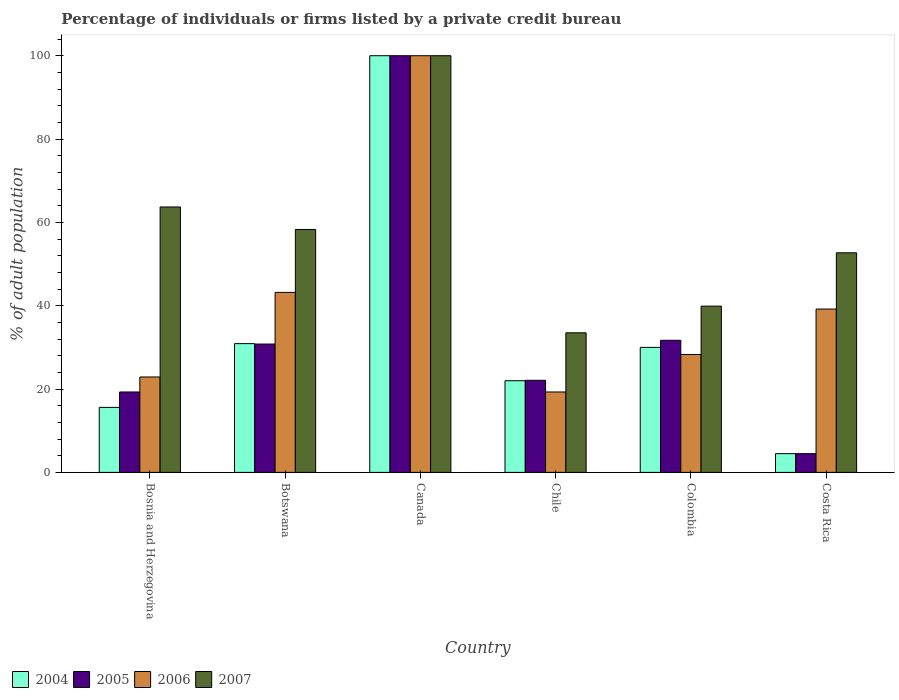How many groups of bars are there?
Make the answer very short. 6. Are the number of bars on each tick of the X-axis equal?
Your answer should be compact. Yes. How many bars are there on the 2nd tick from the right?
Offer a very short reply. 4. What is the percentage of population listed by a private credit bureau in 2005 in Colombia?
Offer a very short reply. 31.7. Across all countries, what is the maximum percentage of population listed by a private credit bureau in 2005?
Your response must be concise. 100. Across all countries, what is the minimum percentage of population listed by a private credit bureau in 2005?
Keep it short and to the point. 4.5. In which country was the percentage of population listed by a private credit bureau in 2005 maximum?
Provide a short and direct response. Canada. In which country was the percentage of population listed by a private credit bureau in 2007 minimum?
Your response must be concise. Chile. What is the total percentage of population listed by a private credit bureau in 2006 in the graph?
Make the answer very short. 252.9. What is the difference between the percentage of population listed by a private credit bureau in 2005 in Bosnia and Herzegovina and that in Canada?
Provide a short and direct response. -80.7. What is the difference between the percentage of population listed by a private credit bureau in 2005 in Canada and the percentage of population listed by a private credit bureau in 2006 in Colombia?
Your answer should be compact. 71.7. What is the average percentage of population listed by a private credit bureau in 2006 per country?
Provide a succinct answer. 42.15. What is the difference between the percentage of population listed by a private credit bureau of/in 2004 and percentage of population listed by a private credit bureau of/in 2005 in Botswana?
Keep it short and to the point. 0.1. In how many countries, is the percentage of population listed by a private credit bureau in 2007 greater than 40 %?
Offer a terse response. 4. What is the ratio of the percentage of population listed by a private credit bureau in 2007 in Canada to that in Costa Rica?
Offer a terse response. 1.9. Is the percentage of population listed by a private credit bureau in 2004 in Colombia less than that in Costa Rica?
Your response must be concise. No. What is the difference between the highest and the second highest percentage of population listed by a private credit bureau in 2007?
Make the answer very short. -41.7. What is the difference between the highest and the lowest percentage of population listed by a private credit bureau in 2006?
Offer a very short reply. 80.7. What does the 4th bar from the left in Chile represents?
Make the answer very short. 2007. What does the 2nd bar from the right in Botswana represents?
Offer a terse response. 2006. Is it the case that in every country, the sum of the percentage of population listed by a private credit bureau in 2004 and percentage of population listed by a private credit bureau in 2007 is greater than the percentage of population listed by a private credit bureau in 2006?
Your answer should be very brief. Yes. How many bars are there?
Keep it short and to the point. 24. What is the difference between two consecutive major ticks on the Y-axis?
Give a very brief answer. 20. Does the graph contain any zero values?
Your answer should be compact. No. Where does the legend appear in the graph?
Offer a terse response. Bottom left. How many legend labels are there?
Provide a succinct answer. 4. How are the legend labels stacked?
Your answer should be very brief. Horizontal. What is the title of the graph?
Make the answer very short. Percentage of individuals or firms listed by a private credit bureau. Does "2015" appear as one of the legend labels in the graph?
Give a very brief answer. No. What is the label or title of the X-axis?
Your answer should be compact. Country. What is the label or title of the Y-axis?
Provide a succinct answer. % of adult population. What is the % of adult population in 2005 in Bosnia and Herzegovina?
Offer a terse response. 19.3. What is the % of adult population of 2006 in Bosnia and Herzegovina?
Give a very brief answer. 22.9. What is the % of adult population of 2007 in Bosnia and Herzegovina?
Keep it short and to the point. 63.7. What is the % of adult population of 2004 in Botswana?
Your answer should be compact. 30.9. What is the % of adult population in 2005 in Botswana?
Provide a short and direct response. 30.8. What is the % of adult population in 2006 in Botswana?
Offer a terse response. 43.2. What is the % of adult population in 2007 in Botswana?
Ensure brevity in your answer.  58.3. What is the % of adult population in 2004 in Canada?
Give a very brief answer. 100. What is the % of adult population in 2005 in Canada?
Keep it short and to the point. 100. What is the % of adult population in 2006 in Canada?
Your answer should be compact. 100. What is the % of adult population of 2004 in Chile?
Your answer should be very brief. 22. What is the % of adult population in 2005 in Chile?
Provide a succinct answer. 22.1. What is the % of adult population in 2006 in Chile?
Your answer should be compact. 19.3. What is the % of adult population of 2007 in Chile?
Your response must be concise. 33.5. What is the % of adult population in 2005 in Colombia?
Offer a terse response. 31.7. What is the % of adult population in 2006 in Colombia?
Ensure brevity in your answer.  28.3. What is the % of adult population of 2007 in Colombia?
Your answer should be very brief. 39.9. What is the % of adult population of 2005 in Costa Rica?
Ensure brevity in your answer.  4.5. What is the % of adult population of 2006 in Costa Rica?
Your response must be concise. 39.2. What is the % of adult population in 2007 in Costa Rica?
Your response must be concise. 52.7. Across all countries, what is the maximum % of adult population of 2005?
Your response must be concise. 100. Across all countries, what is the minimum % of adult population of 2004?
Offer a very short reply. 4.5. Across all countries, what is the minimum % of adult population in 2005?
Provide a succinct answer. 4.5. Across all countries, what is the minimum % of adult population in 2006?
Ensure brevity in your answer.  19.3. Across all countries, what is the minimum % of adult population in 2007?
Your answer should be very brief. 33.5. What is the total % of adult population in 2004 in the graph?
Your answer should be compact. 203. What is the total % of adult population of 2005 in the graph?
Ensure brevity in your answer.  208.4. What is the total % of adult population of 2006 in the graph?
Ensure brevity in your answer.  252.9. What is the total % of adult population of 2007 in the graph?
Keep it short and to the point. 348.1. What is the difference between the % of adult population in 2004 in Bosnia and Herzegovina and that in Botswana?
Provide a short and direct response. -15.3. What is the difference between the % of adult population in 2005 in Bosnia and Herzegovina and that in Botswana?
Keep it short and to the point. -11.5. What is the difference between the % of adult population in 2006 in Bosnia and Herzegovina and that in Botswana?
Give a very brief answer. -20.3. What is the difference between the % of adult population in 2007 in Bosnia and Herzegovina and that in Botswana?
Your answer should be compact. 5.4. What is the difference between the % of adult population in 2004 in Bosnia and Herzegovina and that in Canada?
Provide a succinct answer. -84.4. What is the difference between the % of adult population in 2005 in Bosnia and Herzegovina and that in Canada?
Offer a terse response. -80.7. What is the difference between the % of adult population in 2006 in Bosnia and Herzegovina and that in Canada?
Your response must be concise. -77.1. What is the difference between the % of adult population in 2007 in Bosnia and Herzegovina and that in Canada?
Provide a short and direct response. -36.3. What is the difference between the % of adult population of 2004 in Bosnia and Herzegovina and that in Chile?
Give a very brief answer. -6.4. What is the difference between the % of adult population in 2005 in Bosnia and Herzegovina and that in Chile?
Your answer should be very brief. -2.8. What is the difference between the % of adult population of 2006 in Bosnia and Herzegovina and that in Chile?
Provide a succinct answer. 3.6. What is the difference between the % of adult population of 2007 in Bosnia and Herzegovina and that in Chile?
Your answer should be compact. 30.2. What is the difference between the % of adult population in 2004 in Bosnia and Herzegovina and that in Colombia?
Your response must be concise. -14.4. What is the difference between the % of adult population of 2005 in Bosnia and Herzegovina and that in Colombia?
Provide a short and direct response. -12.4. What is the difference between the % of adult population in 2006 in Bosnia and Herzegovina and that in Colombia?
Offer a terse response. -5.4. What is the difference between the % of adult population of 2007 in Bosnia and Herzegovina and that in Colombia?
Your answer should be very brief. 23.8. What is the difference between the % of adult population of 2005 in Bosnia and Herzegovina and that in Costa Rica?
Offer a terse response. 14.8. What is the difference between the % of adult population in 2006 in Bosnia and Herzegovina and that in Costa Rica?
Your response must be concise. -16.3. What is the difference between the % of adult population in 2004 in Botswana and that in Canada?
Ensure brevity in your answer.  -69.1. What is the difference between the % of adult population of 2005 in Botswana and that in Canada?
Offer a very short reply. -69.2. What is the difference between the % of adult population in 2006 in Botswana and that in Canada?
Ensure brevity in your answer.  -56.8. What is the difference between the % of adult population in 2007 in Botswana and that in Canada?
Make the answer very short. -41.7. What is the difference between the % of adult population in 2004 in Botswana and that in Chile?
Your response must be concise. 8.9. What is the difference between the % of adult population of 2006 in Botswana and that in Chile?
Your response must be concise. 23.9. What is the difference between the % of adult population of 2007 in Botswana and that in Chile?
Provide a short and direct response. 24.8. What is the difference between the % of adult population of 2005 in Botswana and that in Colombia?
Your answer should be compact. -0.9. What is the difference between the % of adult population of 2006 in Botswana and that in Colombia?
Your answer should be compact. 14.9. What is the difference between the % of adult population in 2004 in Botswana and that in Costa Rica?
Make the answer very short. 26.4. What is the difference between the % of adult population in 2005 in Botswana and that in Costa Rica?
Your response must be concise. 26.3. What is the difference between the % of adult population of 2007 in Botswana and that in Costa Rica?
Make the answer very short. 5.6. What is the difference between the % of adult population in 2005 in Canada and that in Chile?
Offer a very short reply. 77.9. What is the difference between the % of adult population in 2006 in Canada and that in Chile?
Make the answer very short. 80.7. What is the difference between the % of adult population of 2007 in Canada and that in Chile?
Provide a short and direct response. 66.5. What is the difference between the % of adult population of 2004 in Canada and that in Colombia?
Offer a very short reply. 70. What is the difference between the % of adult population of 2005 in Canada and that in Colombia?
Give a very brief answer. 68.3. What is the difference between the % of adult population in 2006 in Canada and that in Colombia?
Give a very brief answer. 71.7. What is the difference between the % of adult population of 2007 in Canada and that in Colombia?
Your answer should be compact. 60.1. What is the difference between the % of adult population in 2004 in Canada and that in Costa Rica?
Make the answer very short. 95.5. What is the difference between the % of adult population in 2005 in Canada and that in Costa Rica?
Your answer should be very brief. 95.5. What is the difference between the % of adult population in 2006 in Canada and that in Costa Rica?
Keep it short and to the point. 60.8. What is the difference between the % of adult population in 2007 in Canada and that in Costa Rica?
Keep it short and to the point. 47.3. What is the difference between the % of adult population of 2006 in Chile and that in Colombia?
Give a very brief answer. -9. What is the difference between the % of adult population of 2007 in Chile and that in Colombia?
Give a very brief answer. -6.4. What is the difference between the % of adult population in 2005 in Chile and that in Costa Rica?
Offer a very short reply. 17.6. What is the difference between the % of adult population in 2006 in Chile and that in Costa Rica?
Your answer should be very brief. -19.9. What is the difference between the % of adult population in 2007 in Chile and that in Costa Rica?
Provide a short and direct response. -19.2. What is the difference between the % of adult population in 2004 in Colombia and that in Costa Rica?
Make the answer very short. 25.5. What is the difference between the % of adult population in 2005 in Colombia and that in Costa Rica?
Your response must be concise. 27.2. What is the difference between the % of adult population of 2007 in Colombia and that in Costa Rica?
Offer a very short reply. -12.8. What is the difference between the % of adult population in 2004 in Bosnia and Herzegovina and the % of adult population in 2005 in Botswana?
Your answer should be very brief. -15.2. What is the difference between the % of adult population in 2004 in Bosnia and Herzegovina and the % of adult population in 2006 in Botswana?
Keep it short and to the point. -27.6. What is the difference between the % of adult population in 2004 in Bosnia and Herzegovina and the % of adult population in 2007 in Botswana?
Provide a succinct answer. -42.7. What is the difference between the % of adult population of 2005 in Bosnia and Herzegovina and the % of adult population of 2006 in Botswana?
Your response must be concise. -23.9. What is the difference between the % of adult population in 2005 in Bosnia and Herzegovina and the % of adult population in 2007 in Botswana?
Give a very brief answer. -39. What is the difference between the % of adult population in 2006 in Bosnia and Herzegovina and the % of adult population in 2007 in Botswana?
Make the answer very short. -35.4. What is the difference between the % of adult population in 2004 in Bosnia and Herzegovina and the % of adult population in 2005 in Canada?
Give a very brief answer. -84.4. What is the difference between the % of adult population of 2004 in Bosnia and Herzegovina and the % of adult population of 2006 in Canada?
Provide a succinct answer. -84.4. What is the difference between the % of adult population of 2004 in Bosnia and Herzegovina and the % of adult population of 2007 in Canada?
Give a very brief answer. -84.4. What is the difference between the % of adult population of 2005 in Bosnia and Herzegovina and the % of adult population of 2006 in Canada?
Offer a very short reply. -80.7. What is the difference between the % of adult population of 2005 in Bosnia and Herzegovina and the % of adult population of 2007 in Canada?
Provide a succinct answer. -80.7. What is the difference between the % of adult population in 2006 in Bosnia and Herzegovina and the % of adult population in 2007 in Canada?
Your answer should be compact. -77.1. What is the difference between the % of adult population in 2004 in Bosnia and Herzegovina and the % of adult population in 2006 in Chile?
Offer a terse response. -3.7. What is the difference between the % of adult population of 2004 in Bosnia and Herzegovina and the % of adult population of 2007 in Chile?
Your answer should be very brief. -17.9. What is the difference between the % of adult population in 2005 in Bosnia and Herzegovina and the % of adult population in 2007 in Chile?
Provide a succinct answer. -14.2. What is the difference between the % of adult population of 2004 in Bosnia and Herzegovina and the % of adult population of 2005 in Colombia?
Provide a succinct answer. -16.1. What is the difference between the % of adult population in 2004 in Bosnia and Herzegovina and the % of adult population in 2006 in Colombia?
Offer a very short reply. -12.7. What is the difference between the % of adult population in 2004 in Bosnia and Herzegovina and the % of adult population in 2007 in Colombia?
Ensure brevity in your answer.  -24.3. What is the difference between the % of adult population of 2005 in Bosnia and Herzegovina and the % of adult population of 2007 in Colombia?
Provide a succinct answer. -20.6. What is the difference between the % of adult population in 2006 in Bosnia and Herzegovina and the % of adult population in 2007 in Colombia?
Offer a terse response. -17. What is the difference between the % of adult population of 2004 in Bosnia and Herzegovina and the % of adult population of 2005 in Costa Rica?
Your response must be concise. 11.1. What is the difference between the % of adult population of 2004 in Bosnia and Herzegovina and the % of adult population of 2006 in Costa Rica?
Keep it short and to the point. -23.6. What is the difference between the % of adult population of 2004 in Bosnia and Herzegovina and the % of adult population of 2007 in Costa Rica?
Offer a terse response. -37.1. What is the difference between the % of adult population in 2005 in Bosnia and Herzegovina and the % of adult population in 2006 in Costa Rica?
Ensure brevity in your answer.  -19.9. What is the difference between the % of adult population of 2005 in Bosnia and Herzegovina and the % of adult population of 2007 in Costa Rica?
Ensure brevity in your answer.  -33.4. What is the difference between the % of adult population of 2006 in Bosnia and Herzegovina and the % of adult population of 2007 in Costa Rica?
Give a very brief answer. -29.8. What is the difference between the % of adult population of 2004 in Botswana and the % of adult population of 2005 in Canada?
Your answer should be very brief. -69.1. What is the difference between the % of adult population in 2004 in Botswana and the % of adult population in 2006 in Canada?
Your response must be concise. -69.1. What is the difference between the % of adult population in 2004 in Botswana and the % of adult population in 2007 in Canada?
Offer a very short reply. -69.1. What is the difference between the % of adult population of 2005 in Botswana and the % of adult population of 2006 in Canada?
Keep it short and to the point. -69.2. What is the difference between the % of adult population of 2005 in Botswana and the % of adult population of 2007 in Canada?
Your answer should be very brief. -69.2. What is the difference between the % of adult population in 2006 in Botswana and the % of adult population in 2007 in Canada?
Offer a very short reply. -56.8. What is the difference between the % of adult population of 2004 in Botswana and the % of adult population of 2005 in Chile?
Offer a terse response. 8.8. What is the difference between the % of adult population of 2004 in Botswana and the % of adult population of 2007 in Chile?
Give a very brief answer. -2.6. What is the difference between the % of adult population in 2005 in Botswana and the % of adult population in 2006 in Chile?
Keep it short and to the point. 11.5. What is the difference between the % of adult population in 2005 in Botswana and the % of adult population in 2007 in Chile?
Offer a terse response. -2.7. What is the difference between the % of adult population of 2004 in Botswana and the % of adult population of 2005 in Colombia?
Ensure brevity in your answer.  -0.8. What is the difference between the % of adult population of 2004 in Botswana and the % of adult population of 2007 in Colombia?
Provide a short and direct response. -9. What is the difference between the % of adult population of 2005 in Botswana and the % of adult population of 2006 in Colombia?
Your response must be concise. 2.5. What is the difference between the % of adult population of 2005 in Botswana and the % of adult population of 2007 in Colombia?
Offer a terse response. -9.1. What is the difference between the % of adult population in 2004 in Botswana and the % of adult population in 2005 in Costa Rica?
Provide a succinct answer. 26.4. What is the difference between the % of adult population of 2004 in Botswana and the % of adult population of 2006 in Costa Rica?
Make the answer very short. -8.3. What is the difference between the % of adult population of 2004 in Botswana and the % of adult population of 2007 in Costa Rica?
Give a very brief answer. -21.8. What is the difference between the % of adult population in 2005 in Botswana and the % of adult population in 2007 in Costa Rica?
Make the answer very short. -21.9. What is the difference between the % of adult population in 2006 in Botswana and the % of adult population in 2007 in Costa Rica?
Keep it short and to the point. -9.5. What is the difference between the % of adult population in 2004 in Canada and the % of adult population in 2005 in Chile?
Offer a very short reply. 77.9. What is the difference between the % of adult population of 2004 in Canada and the % of adult population of 2006 in Chile?
Make the answer very short. 80.7. What is the difference between the % of adult population in 2004 in Canada and the % of adult population in 2007 in Chile?
Provide a short and direct response. 66.5. What is the difference between the % of adult population in 2005 in Canada and the % of adult population in 2006 in Chile?
Ensure brevity in your answer.  80.7. What is the difference between the % of adult population in 2005 in Canada and the % of adult population in 2007 in Chile?
Offer a very short reply. 66.5. What is the difference between the % of adult population in 2006 in Canada and the % of adult population in 2007 in Chile?
Give a very brief answer. 66.5. What is the difference between the % of adult population of 2004 in Canada and the % of adult population of 2005 in Colombia?
Your answer should be very brief. 68.3. What is the difference between the % of adult population in 2004 in Canada and the % of adult population in 2006 in Colombia?
Offer a very short reply. 71.7. What is the difference between the % of adult population of 2004 in Canada and the % of adult population of 2007 in Colombia?
Provide a succinct answer. 60.1. What is the difference between the % of adult population of 2005 in Canada and the % of adult population of 2006 in Colombia?
Your answer should be very brief. 71.7. What is the difference between the % of adult population in 2005 in Canada and the % of adult population in 2007 in Colombia?
Provide a succinct answer. 60.1. What is the difference between the % of adult population in 2006 in Canada and the % of adult population in 2007 in Colombia?
Offer a very short reply. 60.1. What is the difference between the % of adult population of 2004 in Canada and the % of adult population of 2005 in Costa Rica?
Your response must be concise. 95.5. What is the difference between the % of adult population in 2004 in Canada and the % of adult population in 2006 in Costa Rica?
Keep it short and to the point. 60.8. What is the difference between the % of adult population in 2004 in Canada and the % of adult population in 2007 in Costa Rica?
Make the answer very short. 47.3. What is the difference between the % of adult population of 2005 in Canada and the % of adult population of 2006 in Costa Rica?
Your answer should be compact. 60.8. What is the difference between the % of adult population in 2005 in Canada and the % of adult population in 2007 in Costa Rica?
Provide a short and direct response. 47.3. What is the difference between the % of adult population in 2006 in Canada and the % of adult population in 2007 in Costa Rica?
Make the answer very short. 47.3. What is the difference between the % of adult population in 2004 in Chile and the % of adult population in 2006 in Colombia?
Provide a short and direct response. -6.3. What is the difference between the % of adult population of 2004 in Chile and the % of adult population of 2007 in Colombia?
Ensure brevity in your answer.  -17.9. What is the difference between the % of adult population in 2005 in Chile and the % of adult population in 2007 in Colombia?
Keep it short and to the point. -17.8. What is the difference between the % of adult population in 2006 in Chile and the % of adult population in 2007 in Colombia?
Your response must be concise. -20.6. What is the difference between the % of adult population of 2004 in Chile and the % of adult population of 2006 in Costa Rica?
Provide a short and direct response. -17.2. What is the difference between the % of adult population of 2004 in Chile and the % of adult population of 2007 in Costa Rica?
Make the answer very short. -30.7. What is the difference between the % of adult population in 2005 in Chile and the % of adult population in 2006 in Costa Rica?
Ensure brevity in your answer.  -17.1. What is the difference between the % of adult population of 2005 in Chile and the % of adult population of 2007 in Costa Rica?
Provide a short and direct response. -30.6. What is the difference between the % of adult population of 2006 in Chile and the % of adult population of 2007 in Costa Rica?
Make the answer very short. -33.4. What is the difference between the % of adult population in 2004 in Colombia and the % of adult population in 2005 in Costa Rica?
Give a very brief answer. 25.5. What is the difference between the % of adult population of 2004 in Colombia and the % of adult population of 2007 in Costa Rica?
Provide a short and direct response. -22.7. What is the difference between the % of adult population in 2005 in Colombia and the % of adult population in 2006 in Costa Rica?
Make the answer very short. -7.5. What is the difference between the % of adult population in 2005 in Colombia and the % of adult population in 2007 in Costa Rica?
Your response must be concise. -21. What is the difference between the % of adult population in 2006 in Colombia and the % of adult population in 2007 in Costa Rica?
Ensure brevity in your answer.  -24.4. What is the average % of adult population of 2004 per country?
Your answer should be very brief. 33.83. What is the average % of adult population in 2005 per country?
Your response must be concise. 34.73. What is the average % of adult population in 2006 per country?
Offer a very short reply. 42.15. What is the average % of adult population of 2007 per country?
Ensure brevity in your answer.  58.02. What is the difference between the % of adult population of 2004 and % of adult population of 2006 in Bosnia and Herzegovina?
Offer a terse response. -7.3. What is the difference between the % of adult population in 2004 and % of adult population in 2007 in Bosnia and Herzegovina?
Give a very brief answer. -48.1. What is the difference between the % of adult population in 2005 and % of adult population in 2007 in Bosnia and Herzegovina?
Ensure brevity in your answer.  -44.4. What is the difference between the % of adult population of 2006 and % of adult population of 2007 in Bosnia and Herzegovina?
Offer a very short reply. -40.8. What is the difference between the % of adult population in 2004 and % of adult population in 2005 in Botswana?
Provide a succinct answer. 0.1. What is the difference between the % of adult population of 2004 and % of adult population of 2006 in Botswana?
Your answer should be very brief. -12.3. What is the difference between the % of adult population in 2004 and % of adult population in 2007 in Botswana?
Make the answer very short. -27.4. What is the difference between the % of adult population of 2005 and % of adult population of 2006 in Botswana?
Your answer should be compact. -12.4. What is the difference between the % of adult population in 2005 and % of adult population in 2007 in Botswana?
Your response must be concise. -27.5. What is the difference between the % of adult population in 2006 and % of adult population in 2007 in Botswana?
Give a very brief answer. -15.1. What is the difference between the % of adult population in 2004 and % of adult population in 2005 in Canada?
Provide a succinct answer. 0. What is the difference between the % of adult population of 2004 and % of adult population of 2006 in Canada?
Your response must be concise. 0. What is the difference between the % of adult population in 2004 and % of adult population in 2007 in Canada?
Offer a terse response. 0. What is the difference between the % of adult population of 2005 and % of adult population of 2006 in Canada?
Keep it short and to the point. 0. What is the difference between the % of adult population of 2005 and % of adult population of 2007 in Canada?
Your answer should be compact. 0. What is the difference between the % of adult population of 2006 and % of adult population of 2007 in Canada?
Offer a very short reply. 0. What is the difference between the % of adult population in 2004 and % of adult population in 2005 in Chile?
Offer a very short reply. -0.1. What is the difference between the % of adult population of 2004 and % of adult population of 2006 in Chile?
Offer a very short reply. 2.7. What is the difference between the % of adult population of 2005 and % of adult population of 2007 in Chile?
Your answer should be very brief. -11.4. What is the difference between the % of adult population of 2004 and % of adult population of 2005 in Colombia?
Offer a very short reply. -1.7. What is the difference between the % of adult population in 2004 and % of adult population in 2006 in Colombia?
Ensure brevity in your answer.  1.7. What is the difference between the % of adult population of 2004 and % of adult population of 2007 in Colombia?
Offer a very short reply. -9.9. What is the difference between the % of adult population of 2005 and % of adult population of 2007 in Colombia?
Give a very brief answer. -8.2. What is the difference between the % of adult population in 2004 and % of adult population in 2006 in Costa Rica?
Give a very brief answer. -34.7. What is the difference between the % of adult population of 2004 and % of adult population of 2007 in Costa Rica?
Ensure brevity in your answer.  -48.2. What is the difference between the % of adult population in 2005 and % of adult population in 2006 in Costa Rica?
Provide a succinct answer. -34.7. What is the difference between the % of adult population in 2005 and % of adult population in 2007 in Costa Rica?
Your answer should be very brief. -48.2. What is the ratio of the % of adult population in 2004 in Bosnia and Herzegovina to that in Botswana?
Offer a very short reply. 0.5. What is the ratio of the % of adult population in 2005 in Bosnia and Herzegovina to that in Botswana?
Offer a terse response. 0.63. What is the ratio of the % of adult population in 2006 in Bosnia and Herzegovina to that in Botswana?
Give a very brief answer. 0.53. What is the ratio of the % of adult population in 2007 in Bosnia and Herzegovina to that in Botswana?
Your answer should be compact. 1.09. What is the ratio of the % of adult population of 2004 in Bosnia and Herzegovina to that in Canada?
Your response must be concise. 0.16. What is the ratio of the % of adult population of 2005 in Bosnia and Herzegovina to that in Canada?
Your answer should be compact. 0.19. What is the ratio of the % of adult population of 2006 in Bosnia and Herzegovina to that in Canada?
Ensure brevity in your answer.  0.23. What is the ratio of the % of adult population in 2007 in Bosnia and Herzegovina to that in Canada?
Ensure brevity in your answer.  0.64. What is the ratio of the % of adult population of 2004 in Bosnia and Herzegovina to that in Chile?
Provide a succinct answer. 0.71. What is the ratio of the % of adult population of 2005 in Bosnia and Herzegovina to that in Chile?
Your answer should be compact. 0.87. What is the ratio of the % of adult population of 2006 in Bosnia and Herzegovina to that in Chile?
Give a very brief answer. 1.19. What is the ratio of the % of adult population in 2007 in Bosnia and Herzegovina to that in Chile?
Provide a short and direct response. 1.9. What is the ratio of the % of adult population of 2004 in Bosnia and Herzegovina to that in Colombia?
Provide a succinct answer. 0.52. What is the ratio of the % of adult population in 2005 in Bosnia and Herzegovina to that in Colombia?
Provide a short and direct response. 0.61. What is the ratio of the % of adult population of 2006 in Bosnia and Herzegovina to that in Colombia?
Give a very brief answer. 0.81. What is the ratio of the % of adult population of 2007 in Bosnia and Herzegovina to that in Colombia?
Provide a succinct answer. 1.6. What is the ratio of the % of adult population in 2004 in Bosnia and Herzegovina to that in Costa Rica?
Keep it short and to the point. 3.47. What is the ratio of the % of adult population in 2005 in Bosnia and Herzegovina to that in Costa Rica?
Your answer should be compact. 4.29. What is the ratio of the % of adult population of 2006 in Bosnia and Herzegovina to that in Costa Rica?
Provide a succinct answer. 0.58. What is the ratio of the % of adult population in 2007 in Bosnia and Herzegovina to that in Costa Rica?
Keep it short and to the point. 1.21. What is the ratio of the % of adult population in 2004 in Botswana to that in Canada?
Offer a very short reply. 0.31. What is the ratio of the % of adult population of 2005 in Botswana to that in Canada?
Keep it short and to the point. 0.31. What is the ratio of the % of adult population in 2006 in Botswana to that in Canada?
Make the answer very short. 0.43. What is the ratio of the % of adult population in 2007 in Botswana to that in Canada?
Your response must be concise. 0.58. What is the ratio of the % of adult population in 2004 in Botswana to that in Chile?
Offer a very short reply. 1.4. What is the ratio of the % of adult population of 2005 in Botswana to that in Chile?
Ensure brevity in your answer.  1.39. What is the ratio of the % of adult population in 2006 in Botswana to that in Chile?
Your response must be concise. 2.24. What is the ratio of the % of adult population in 2007 in Botswana to that in Chile?
Offer a terse response. 1.74. What is the ratio of the % of adult population of 2005 in Botswana to that in Colombia?
Offer a terse response. 0.97. What is the ratio of the % of adult population in 2006 in Botswana to that in Colombia?
Provide a succinct answer. 1.53. What is the ratio of the % of adult population of 2007 in Botswana to that in Colombia?
Your answer should be very brief. 1.46. What is the ratio of the % of adult population in 2004 in Botswana to that in Costa Rica?
Make the answer very short. 6.87. What is the ratio of the % of adult population in 2005 in Botswana to that in Costa Rica?
Make the answer very short. 6.84. What is the ratio of the % of adult population of 2006 in Botswana to that in Costa Rica?
Offer a terse response. 1.1. What is the ratio of the % of adult population of 2007 in Botswana to that in Costa Rica?
Make the answer very short. 1.11. What is the ratio of the % of adult population of 2004 in Canada to that in Chile?
Offer a terse response. 4.55. What is the ratio of the % of adult population in 2005 in Canada to that in Chile?
Your answer should be compact. 4.52. What is the ratio of the % of adult population of 2006 in Canada to that in Chile?
Your response must be concise. 5.18. What is the ratio of the % of adult population in 2007 in Canada to that in Chile?
Provide a short and direct response. 2.99. What is the ratio of the % of adult population of 2004 in Canada to that in Colombia?
Provide a succinct answer. 3.33. What is the ratio of the % of adult population in 2005 in Canada to that in Colombia?
Your answer should be compact. 3.15. What is the ratio of the % of adult population of 2006 in Canada to that in Colombia?
Your answer should be compact. 3.53. What is the ratio of the % of adult population in 2007 in Canada to that in Colombia?
Offer a terse response. 2.51. What is the ratio of the % of adult population in 2004 in Canada to that in Costa Rica?
Provide a short and direct response. 22.22. What is the ratio of the % of adult population in 2005 in Canada to that in Costa Rica?
Provide a short and direct response. 22.22. What is the ratio of the % of adult population in 2006 in Canada to that in Costa Rica?
Give a very brief answer. 2.55. What is the ratio of the % of adult population of 2007 in Canada to that in Costa Rica?
Provide a succinct answer. 1.9. What is the ratio of the % of adult population of 2004 in Chile to that in Colombia?
Make the answer very short. 0.73. What is the ratio of the % of adult population of 2005 in Chile to that in Colombia?
Your response must be concise. 0.7. What is the ratio of the % of adult population in 2006 in Chile to that in Colombia?
Your response must be concise. 0.68. What is the ratio of the % of adult population in 2007 in Chile to that in Colombia?
Provide a short and direct response. 0.84. What is the ratio of the % of adult population of 2004 in Chile to that in Costa Rica?
Your response must be concise. 4.89. What is the ratio of the % of adult population of 2005 in Chile to that in Costa Rica?
Keep it short and to the point. 4.91. What is the ratio of the % of adult population in 2006 in Chile to that in Costa Rica?
Offer a terse response. 0.49. What is the ratio of the % of adult population in 2007 in Chile to that in Costa Rica?
Ensure brevity in your answer.  0.64. What is the ratio of the % of adult population in 2004 in Colombia to that in Costa Rica?
Keep it short and to the point. 6.67. What is the ratio of the % of adult population in 2005 in Colombia to that in Costa Rica?
Your response must be concise. 7.04. What is the ratio of the % of adult population in 2006 in Colombia to that in Costa Rica?
Keep it short and to the point. 0.72. What is the ratio of the % of adult population of 2007 in Colombia to that in Costa Rica?
Your response must be concise. 0.76. What is the difference between the highest and the second highest % of adult population of 2004?
Ensure brevity in your answer.  69.1. What is the difference between the highest and the second highest % of adult population of 2005?
Provide a succinct answer. 68.3. What is the difference between the highest and the second highest % of adult population of 2006?
Offer a very short reply. 56.8. What is the difference between the highest and the second highest % of adult population of 2007?
Provide a succinct answer. 36.3. What is the difference between the highest and the lowest % of adult population in 2004?
Offer a very short reply. 95.5. What is the difference between the highest and the lowest % of adult population in 2005?
Provide a succinct answer. 95.5. What is the difference between the highest and the lowest % of adult population in 2006?
Give a very brief answer. 80.7. What is the difference between the highest and the lowest % of adult population of 2007?
Your answer should be very brief. 66.5. 